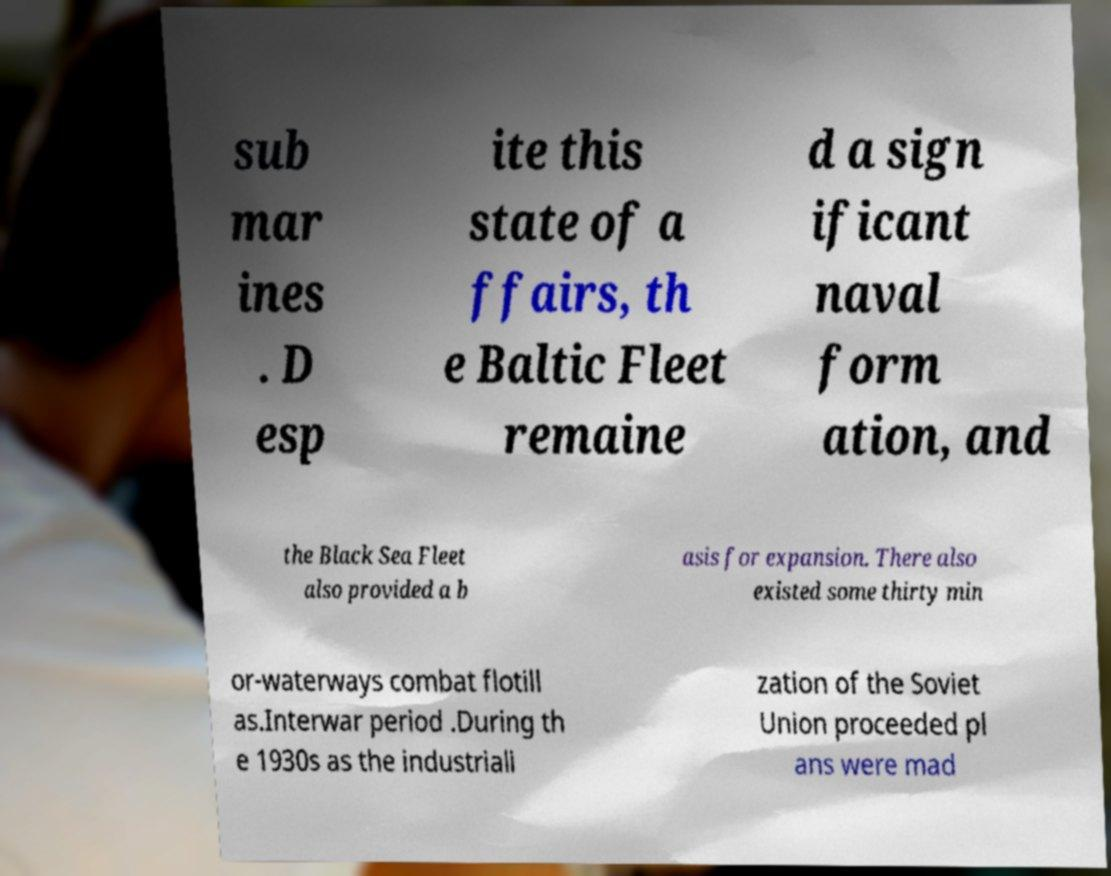For documentation purposes, I need the text within this image transcribed. Could you provide that? sub mar ines . D esp ite this state of a ffairs, th e Baltic Fleet remaine d a sign ificant naval form ation, and the Black Sea Fleet also provided a b asis for expansion. There also existed some thirty min or-waterways combat flotill as.Interwar period .During th e 1930s as the industriali zation of the Soviet Union proceeded pl ans were mad 